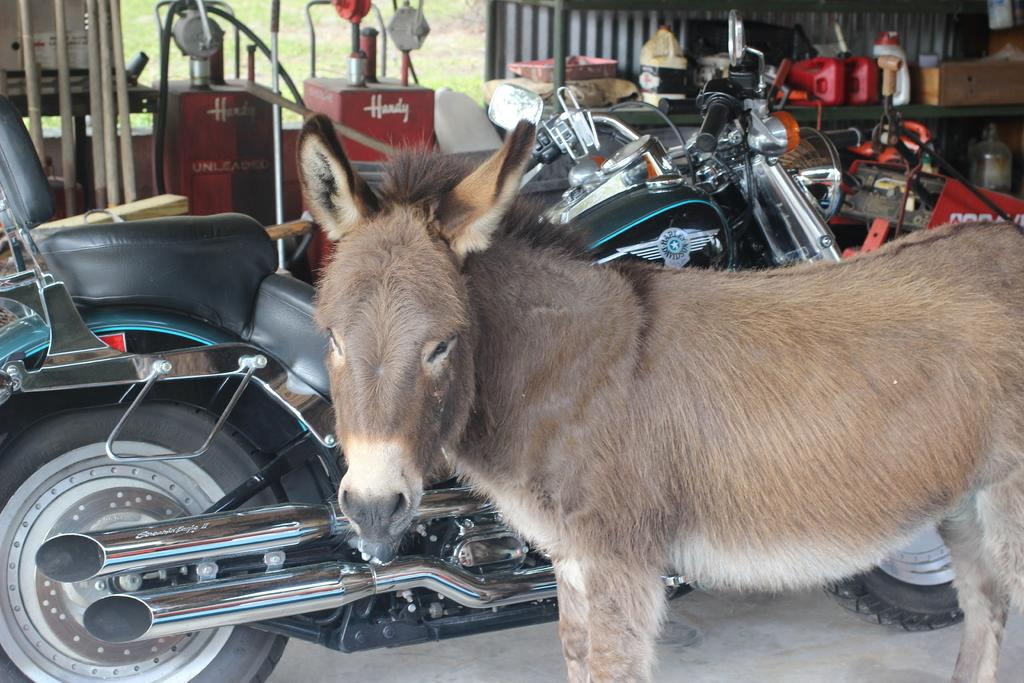What animal is present in the image? There is a donkey in the image. What mode of transportation can be seen in the image? There is a motorcycle in the image. What objects are visible in the background of the image? There are bottles, machines, metal rods, and grass in the background of the image. What type of humor can be seen in the image? There is no humor present in the image; it is a straightforward depiction of a donkey and a motorcycle with various objects in the background. 